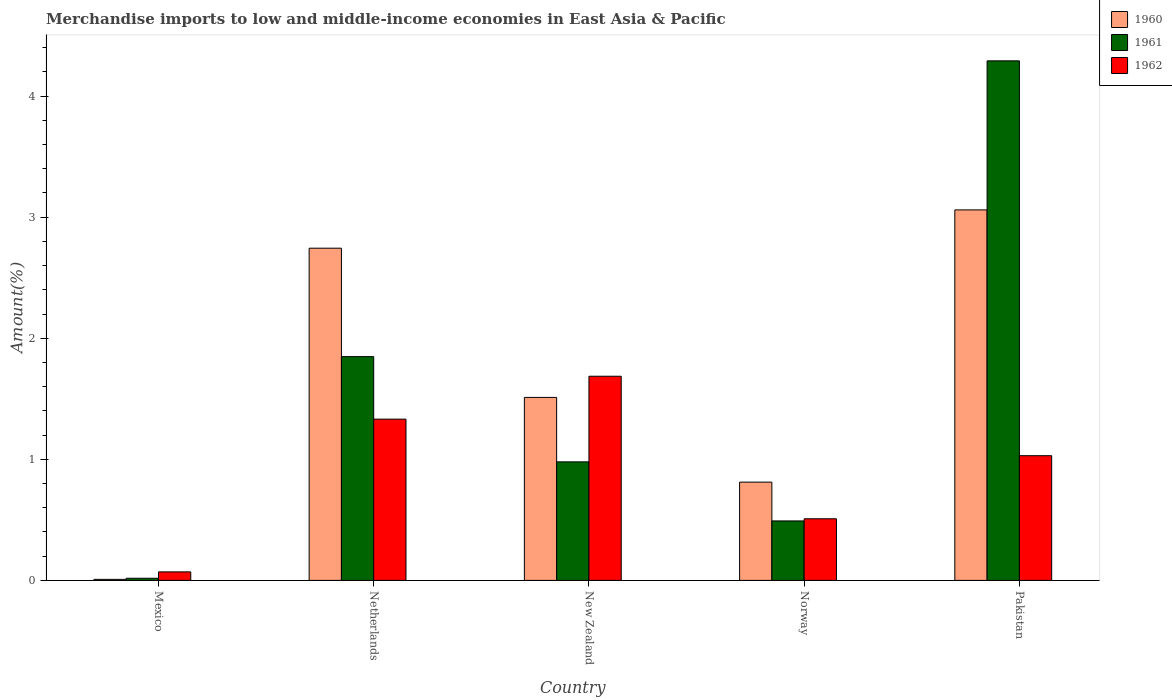How many different coloured bars are there?
Provide a short and direct response. 3. How many groups of bars are there?
Provide a short and direct response. 5. Are the number of bars on each tick of the X-axis equal?
Keep it short and to the point. Yes. How many bars are there on the 5th tick from the right?
Your response must be concise. 3. What is the label of the 4th group of bars from the left?
Your answer should be very brief. Norway. What is the percentage of amount earned from merchandise imports in 1962 in Pakistan?
Ensure brevity in your answer.  1.03. Across all countries, what is the maximum percentage of amount earned from merchandise imports in 1962?
Your answer should be very brief. 1.69. Across all countries, what is the minimum percentage of amount earned from merchandise imports in 1962?
Keep it short and to the point. 0.07. In which country was the percentage of amount earned from merchandise imports in 1962 maximum?
Your response must be concise. New Zealand. What is the total percentage of amount earned from merchandise imports in 1961 in the graph?
Your answer should be compact. 7.63. What is the difference between the percentage of amount earned from merchandise imports in 1962 in Mexico and that in New Zealand?
Keep it short and to the point. -1.62. What is the difference between the percentage of amount earned from merchandise imports in 1960 in New Zealand and the percentage of amount earned from merchandise imports in 1962 in Netherlands?
Your answer should be compact. 0.18. What is the average percentage of amount earned from merchandise imports in 1962 per country?
Offer a terse response. 0.93. What is the difference between the percentage of amount earned from merchandise imports of/in 1962 and percentage of amount earned from merchandise imports of/in 1961 in Netherlands?
Your answer should be compact. -0.52. What is the ratio of the percentage of amount earned from merchandise imports in 1961 in Netherlands to that in Pakistan?
Your response must be concise. 0.43. What is the difference between the highest and the second highest percentage of amount earned from merchandise imports in 1961?
Give a very brief answer. -0.87. What is the difference between the highest and the lowest percentage of amount earned from merchandise imports in 1962?
Ensure brevity in your answer.  1.62. In how many countries, is the percentage of amount earned from merchandise imports in 1962 greater than the average percentage of amount earned from merchandise imports in 1962 taken over all countries?
Offer a terse response. 3. Is the sum of the percentage of amount earned from merchandise imports in 1960 in Mexico and New Zealand greater than the maximum percentage of amount earned from merchandise imports in 1961 across all countries?
Your response must be concise. No. How many bars are there?
Your answer should be compact. 15. Are all the bars in the graph horizontal?
Ensure brevity in your answer.  No. How many countries are there in the graph?
Give a very brief answer. 5. Are the values on the major ticks of Y-axis written in scientific E-notation?
Offer a terse response. No. Does the graph contain any zero values?
Provide a short and direct response. No. Does the graph contain grids?
Your response must be concise. No. How are the legend labels stacked?
Your response must be concise. Vertical. What is the title of the graph?
Offer a very short reply. Merchandise imports to low and middle-income economies in East Asia & Pacific. Does "1965" appear as one of the legend labels in the graph?
Keep it short and to the point. No. What is the label or title of the X-axis?
Keep it short and to the point. Country. What is the label or title of the Y-axis?
Make the answer very short. Amount(%). What is the Amount(%) of 1960 in Mexico?
Your answer should be very brief. 0.01. What is the Amount(%) in 1961 in Mexico?
Offer a very short reply. 0.02. What is the Amount(%) of 1962 in Mexico?
Your answer should be compact. 0.07. What is the Amount(%) in 1960 in Netherlands?
Offer a terse response. 2.74. What is the Amount(%) in 1961 in Netherlands?
Your response must be concise. 1.85. What is the Amount(%) of 1962 in Netherlands?
Offer a very short reply. 1.33. What is the Amount(%) of 1960 in New Zealand?
Offer a terse response. 1.51. What is the Amount(%) of 1961 in New Zealand?
Make the answer very short. 0.98. What is the Amount(%) of 1962 in New Zealand?
Offer a terse response. 1.69. What is the Amount(%) of 1960 in Norway?
Provide a short and direct response. 0.81. What is the Amount(%) of 1961 in Norway?
Your response must be concise. 0.49. What is the Amount(%) of 1962 in Norway?
Provide a short and direct response. 0.51. What is the Amount(%) of 1960 in Pakistan?
Give a very brief answer. 3.06. What is the Amount(%) in 1961 in Pakistan?
Provide a short and direct response. 4.29. What is the Amount(%) of 1962 in Pakistan?
Keep it short and to the point. 1.03. Across all countries, what is the maximum Amount(%) in 1960?
Offer a very short reply. 3.06. Across all countries, what is the maximum Amount(%) in 1961?
Give a very brief answer. 4.29. Across all countries, what is the maximum Amount(%) of 1962?
Make the answer very short. 1.69. Across all countries, what is the minimum Amount(%) in 1960?
Give a very brief answer. 0.01. Across all countries, what is the minimum Amount(%) in 1961?
Provide a succinct answer. 0.02. Across all countries, what is the minimum Amount(%) in 1962?
Provide a short and direct response. 0.07. What is the total Amount(%) in 1960 in the graph?
Provide a succinct answer. 8.14. What is the total Amount(%) in 1961 in the graph?
Make the answer very short. 7.63. What is the total Amount(%) in 1962 in the graph?
Ensure brevity in your answer.  4.63. What is the difference between the Amount(%) in 1960 in Mexico and that in Netherlands?
Your answer should be compact. -2.74. What is the difference between the Amount(%) of 1961 in Mexico and that in Netherlands?
Your response must be concise. -1.83. What is the difference between the Amount(%) of 1962 in Mexico and that in Netherlands?
Your answer should be compact. -1.26. What is the difference between the Amount(%) of 1960 in Mexico and that in New Zealand?
Give a very brief answer. -1.5. What is the difference between the Amount(%) of 1961 in Mexico and that in New Zealand?
Your response must be concise. -0.96. What is the difference between the Amount(%) of 1962 in Mexico and that in New Zealand?
Offer a terse response. -1.62. What is the difference between the Amount(%) in 1960 in Mexico and that in Norway?
Provide a short and direct response. -0.8. What is the difference between the Amount(%) of 1961 in Mexico and that in Norway?
Provide a succinct answer. -0.47. What is the difference between the Amount(%) in 1962 in Mexico and that in Norway?
Provide a succinct answer. -0.44. What is the difference between the Amount(%) in 1960 in Mexico and that in Pakistan?
Offer a terse response. -3.05. What is the difference between the Amount(%) in 1961 in Mexico and that in Pakistan?
Your answer should be very brief. -4.27. What is the difference between the Amount(%) of 1962 in Mexico and that in Pakistan?
Your answer should be very brief. -0.96. What is the difference between the Amount(%) in 1960 in Netherlands and that in New Zealand?
Provide a succinct answer. 1.23. What is the difference between the Amount(%) in 1961 in Netherlands and that in New Zealand?
Your answer should be compact. 0.87. What is the difference between the Amount(%) in 1962 in Netherlands and that in New Zealand?
Ensure brevity in your answer.  -0.35. What is the difference between the Amount(%) of 1960 in Netherlands and that in Norway?
Your response must be concise. 1.93. What is the difference between the Amount(%) in 1961 in Netherlands and that in Norway?
Give a very brief answer. 1.36. What is the difference between the Amount(%) of 1962 in Netherlands and that in Norway?
Offer a terse response. 0.82. What is the difference between the Amount(%) of 1960 in Netherlands and that in Pakistan?
Your answer should be compact. -0.32. What is the difference between the Amount(%) of 1961 in Netherlands and that in Pakistan?
Give a very brief answer. -2.44. What is the difference between the Amount(%) of 1962 in Netherlands and that in Pakistan?
Offer a very short reply. 0.3. What is the difference between the Amount(%) of 1960 in New Zealand and that in Norway?
Your response must be concise. 0.7. What is the difference between the Amount(%) of 1961 in New Zealand and that in Norway?
Make the answer very short. 0.49. What is the difference between the Amount(%) of 1962 in New Zealand and that in Norway?
Provide a succinct answer. 1.18. What is the difference between the Amount(%) in 1960 in New Zealand and that in Pakistan?
Offer a terse response. -1.55. What is the difference between the Amount(%) of 1961 in New Zealand and that in Pakistan?
Offer a very short reply. -3.31. What is the difference between the Amount(%) in 1962 in New Zealand and that in Pakistan?
Offer a very short reply. 0.66. What is the difference between the Amount(%) in 1960 in Norway and that in Pakistan?
Your response must be concise. -2.25. What is the difference between the Amount(%) of 1961 in Norway and that in Pakistan?
Your response must be concise. -3.8. What is the difference between the Amount(%) in 1962 in Norway and that in Pakistan?
Your response must be concise. -0.52. What is the difference between the Amount(%) in 1960 in Mexico and the Amount(%) in 1961 in Netherlands?
Your response must be concise. -1.84. What is the difference between the Amount(%) of 1960 in Mexico and the Amount(%) of 1962 in Netherlands?
Make the answer very short. -1.32. What is the difference between the Amount(%) in 1961 in Mexico and the Amount(%) in 1962 in Netherlands?
Make the answer very short. -1.31. What is the difference between the Amount(%) of 1960 in Mexico and the Amount(%) of 1961 in New Zealand?
Provide a succinct answer. -0.97. What is the difference between the Amount(%) of 1960 in Mexico and the Amount(%) of 1962 in New Zealand?
Offer a terse response. -1.68. What is the difference between the Amount(%) of 1961 in Mexico and the Amount(%) of 1962 in New Zealand?
Give a very brief answer. -1.67. What is the difference between the Amount(%) in 1960 in Mexico and the Amount(%) in 1961 in Norway?
Offer a very short reply. -0.48. What is the difference between the Amount(%) in 1960 in Mexico and the Amount(%) in 1962 in Norway?
Offer a terse response. -0.5. What is the difference between the Amount(%) in 1961 in Mexico and the Amount(%) in 1962 in Norway?
Offer a very short reply. -0.49. What is the difference between the Amount(%) of 1960 in Mexico and the Amount(%) of 1961 in Pakistan?
Provide a succinct answer. -4.28. What is the difference between the Amount(%) in 1960 in Mexico and the Amount(%) in 1962 in Pakistan?
Your answer should be compact. -1.02. What is the difference between the Amount(%) in 1961 in Mexico and the Amount(%) in 1962 in Pakistan?
Offer a very short reply. -1.01. What is the difference between the Amount(%) of 1960 in Netherlands and the Amount(%) of 1961 in New Zealand?
Provide a short and direct response. 1.76. What is the difference between the Amount(%) in 1960 in Netherlands and the Amount(%) in 1962 in New Zealand?
Give a very brief answer. 1.06. What is the difference between the Amount(%) of 1961 in Netherlands and the Amount(%) of 1962 in New Zealand?
Make the answer very short. 0.16. What is the difference between the Amount(%) in 1960 in Netherlands and the Amount(%) in 1961 in Norway?
Give a very brief answer. 2.25. What is the difference between the Amount(%) in 1960 in Netherlands and the Amount(%) in 1962 in Norway?
Offer a terse response. 2.23. What is the difference between the Amount(%) of 1961 in Netherlands and the Amount(%) of 1962 in Norway?
Provide a succinct answer. 1.34. What is the difference between the Amount(%) in 1960 in Netherlands and the Amount(%) in 1961 in Pakistan?
Your response must be concise. -1.55. What is the difference between the Amount(%) in 1960 in Netherlands and the Amount(%) in 1962 in Pakistan?
Make the answer very short. 1.71. What is the difference between the Amount(%) of 1961 in Netherlands and the Amount(%) of 1962 in Pakistan?
Ensure brevity in your answer.  0.82. What is the difference between the Amount(%) in 1960 in New Zealand and the Amount(%) in 1961 in Norway?
Ensure brevity in your answer.  1.02. What is the difference between the Amount(%) in 1960 in New Zealand and the Amount(%) in 1962 in Norway?
Ensure brevity in your answer.  1. What is the difference between the Amount(%) in 1961 in New Zealand and the Amount(%) in 1962 in Norway?
Give a very brief answer. 0.47. What is the difference between the Amount(%) in 1960 in New Zealand and the Amount(%) in 1961 in Pakistan?
Ensure brevity in your answer.  -2.78. What is the difference between the Amount(%) of 1960 in New Zealand and the Amount(%) of 1962 in Pakistan?
Your answer should be very brief. 0.48. What is the difference between the Amount(%) in 1961 in New Zealand and the Amount(%) in 1962 in Pakistan?
Your answer should be compact. -0.05. What is the difference between the Amount(%) in 1960 in Norway and the Amount(%) in 1961 in Pakistan?
Ensure brevity in your answer.  -3.48. What is the difference between the Amount(%) in 1960 in Norway and the Amount(%) in 1962 in Pakistan?
Offer a very short reply. -0.22. What is the difference between the Amount(%) in 1961 in Norway and the Amount(%) in 1962 in Pakistan?
Make the answer very short. -0.54. What is the average Amount(%) of 1960 per country?
Make the answer very short. 1.63. What is the average Amount(%) in 1961 per country?
Your answer should be compact. 1.53. What is the average Amount(%) of 1962 per country?
Offer a terse response. 0.93. What is the difference between the Amount(%) of 1960 and Amount(%) of 1961 in Mexico?
Offer a very short reply. -0.01. What is the difference between the Amount(%) in 1960 and Amount(%) in 1962 in Mexico?
Offer a terse response. -0.06. What is the difference between the Amount(%) in 1961 and Amount(%) in 1962 in Mexico?
Your answer should be very brief. -0.05. What is the difference between the Amount(%) in 1960 and Amount(%) in 1961 in Netherlands?
Your response must be concise. 0.9. What is the difference between the Amount(%) of 1960 and Amount(%) of 1962 in Netherlands?
Make the answer very short. 1.41. What is the difference between the Amount(%) of 1961 and Amount(%) of 1962 in Netherlands?
Provide a short and direct response. 0.52. What is the difference between the Amount(%) in 1960 and Amount(%) in 1961 in New Zealand?
Keep it short and to the point. 0.53. What is the difference between the Amount(%) in 1960 and Amount(%) in 1962 in New Zealand?
Ensure brevity in your answer.  -0.17. What is the difference between the Amount(%) of 1961 and Amount(%) of 1962 in New Zealand?
Your response must be concise. -0.71. What is the difference between the Amount(%) of 1960 and Amount(%) of 1961 in Norway?
Keep it short and to the point. 0.32. What is the difference between the Amount(%) in 1960 and Amount(%) in 1962 in Norway?
Offer a terse response. 0.3. What is the difference between the Amount(%) of 1961 and Amount(%) of 1962 in Norway?
Ensure brevity in your answer.  -0.02. What is the difference between the Amount(%) of 1960 and Amount(%) of 1961 in Pakistan?
Make the answer very short. -1.23. What is the difference between the Amount(%) of 1960 and Amount(%) of 1962 in Pakistan?
Ensure brevity in your answer.  2.03. What is the difference between the Amount(%) in 1961 and Amount(%) in 1962 in Pakistan?
Give a very brief answer. 3.26. What is the ratio of the Amount(%) of 1960 in Mexico to that in Netherlands?
Offer a terse response. 0. What is the ratio of the Amount(%) in 1961 in Mexico to that in Netherlands?
Your response must be concise. 0.01. What is the ratio of the Amount(%) in 1962 in Mexico to that in Netherlands?
Provide a succinct answer. 0.05. What is the ratio of the Amount(%) of 1960 in Mexico to that in New Zealand?
Ensure brevity in your answer.  0.01. What is the ratio of the Amount(%) of 1961 in Mexico to that in New Zealand?
Offer a terse response. 0.02. What is the ratio of the Amount(%) of 1962 in Mexico to that in New Zealand?
Provide a short and direct response. 0.04. What is the ratio of the Amount(%) in 1960 in Mexico to that in Norway?
Keep it short and to the point. 0.01. What is the ratio of the Amount(%) of 1961 in Mexico to that in Norway?
Give a very brief answer. 0.04. What is the ratio of the Amount(%) of 1962 in Mexico to that in Norway?
Make the answer very short. 0.14. What is the ratio of the Amount(%) of 1960 in Mexico to that in Pakistan?
Provide a succinct answer. 0. What is the ratio of the Amount(%) in 1961 in Mexico to that in Pakistan?
Make the answer very short. 0. What is the ratio of the Amount(%) of 1962 in Mexico to that in Pakistan?
Make the answer very short. 0.07. What is the ratio of the Amount(%) of 1960 in Netherlands to that in New Zealand?
Your answer should be very brief. 1.82. What is the ratio of the Amount(%) in 1961 in Netherlands to that in New Zealand?
Offer a terse response. 1.89. What is the ratio of the Amount(%) in 1962 in Netherlands to that in New Zealand?
Your answer should be very brief. 0.79. What is the ratio of the Amount(%) in 1960 in Netherlands to that in Norway?
Give a very brief answer. 3.38. What is the ratio of the Amount(%) in 1961 in Netherlands to that in Norway?
Your answer should be compact. 3.76. What is the ratio of the Amount(%) of 1962 in Netherlands to that in Norway?
Ensure brevity in your answer.  2.62. What is the ratio of the Amount(%) of 1960 in Netherlands to that in Pakistan?
Provide a succinct answer. 0.9. What is the ratio of the Amount(%) of 1961 in Netherlands to that in Pakistan?
Your answer should be very brief. 0.43. What is the ratio of the Amount(%) of 1962 in Netherlands to that in Pakistan?
Provide a succinct answer. 1.29. What is the ratio of the Amount(%) of 1960 in New Zealand to that in Norway?
Give a very brief answer. 1.86. What is the ratio of the Amount(%) of 1961 in New Zealand to that in Norway?
Offer a terse response. 1.99. What is the ratio of the Amount(%) of 1962 in New Zealand to that in Norway?
Ensure brevity in your answer.  3.31. What is the ratio of the Amount(%) of 1960 in New Zealand to that in Pakistan?
Keep it short and to the point. 0.49. What is the ratio of the Amount(%) in 1961 in New Zealand to that in Pakistan?
Offer a terse response. 0.23. What is the ratio of the Amount(%) in 1962 in New Zealand to that in Pakistan?
Your answer should be very brief. 1.64. What is the ratio of the Amount(%) of 1960 in Norway to that in Pakistan?
Offer a terse response. 0.27. What is the ratio of the Amount(%) of 1961 in Norway to that in Pakistan?
Keep it short and to the point. 0.11. What is the ratio of the Amount(%) in 1962 in Norway to that in Pakistan?
Your answer should be very brief. 0.49. What is the difference between the highest and the second highest Amount(%) in 1960?
Give a very brief answer. 0.32. What is the difference between the highest and the second highest Amount(%) in 1961?
Make the answer very short. 2.44. What is the difference between the highest and the second highest Amount(%) of 1962?
Offer a terse response. 0.35. What is the difference between the highest and the lowest Amount(%) in 1960?
Your answer should be very brief. 3.05. What is the difference between the highest and the lowest Amount(%) in 1961?
Offer a terse response. 4.27. What is the difference between the highest and the lowest Amount(%) of 1962?
Keep it short and to the point. 1.62. 